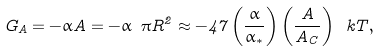Convert formula to latex. <formula><loc_0><loc_0><loc_500><loc_500>G _ { A } = - \alpha A = - \alpha \ \pi R ^ { 2 } \approx - 4 7 \left ( \frac { \alpha } { \alpha _ { * } } \right ) \left ( \frac { A } { A _ { C } } \right ) \ k T ,</formula> 